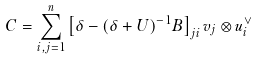Convert formula to latex. <formula><loc_0><loc_0><loc_500><loc_500>C = \sum _ { i , j = 1 } ^ { n } \left [ \delta - ( \delta + U ) ^ { - 1 } B \right ] _ { j i } v _ { j } \otimes u _ { i } ^ { \vee }</formula> 